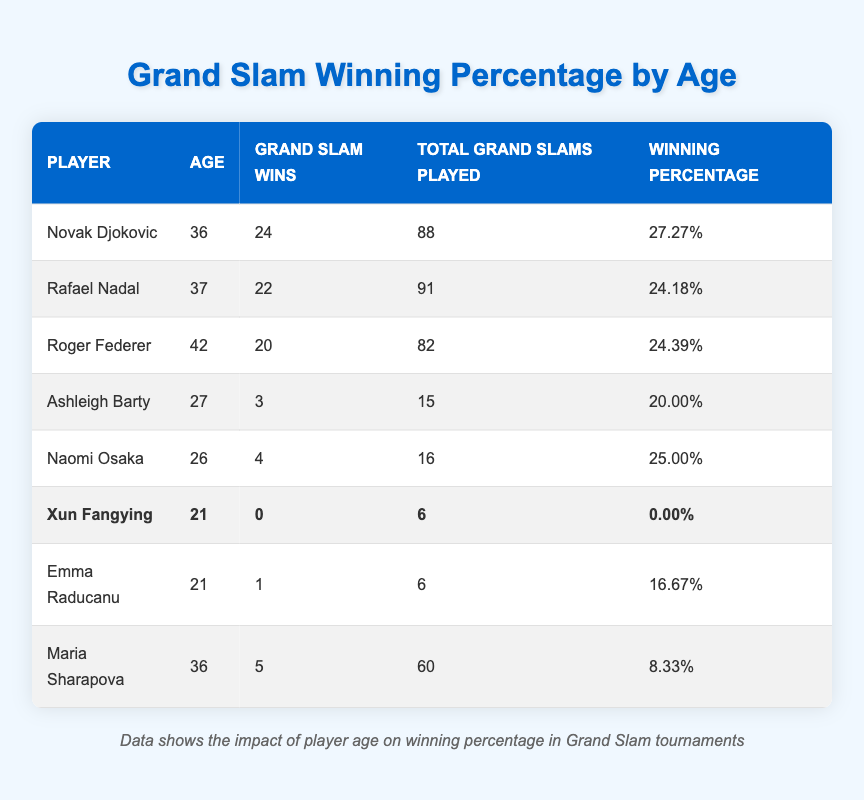What is the highest winning percentage in the table? To find the highest winning percentage, I will scan through the "Winning Percentage" column in the table. The players listed are Novak Djokovic with 27.27%, Rafael Nadal with 24.18%, Roger Federer with 24.39%, Ashleigh Barty with 20.00%, Naomi Osaka with 25.00%, Xun Fangying with 0.00%, Emma Raducanu with 16.67%, and Maria Sharapova with 8.33%. The highest among these is 27.27%, which belongs to Novak Djokovic.
Answer: 27.27% What is the average age of all players in the table? To find the average age, I will sum the ages of all players listed in the "Age" column: 36 + 37 + 42 + 27 + 26 + 21 + 21 + 36 = 306. There are 8 players in total. Therefore, the average age is 306 divided by 8, which equals 38.25.
Answer: 38.25 Does Xun Fangying have any Grand Slam wins? I will check the "Grand Slam Wins" column for Xun Fangying. According to the table, she has 0 Grand Slam wins. Since the value is explicitly stated as 0, the answer is no.
Answer: No Who has the lowest winning percentage in the table? To find the lowest winning percentage, I will look through the "Winning Percentage" column. Xun Fangying has a winning percentage of 0.00%, which is the lowest. All other percentages are higher than this value. Therefore, the answer is Xun Fangying.
Answer: Xun Fangying What is the difference in the number of Grand Slam wins between the oldest player and the youngest player? The oldest player is Roger Federer at age 42 with 20 Grand Slam wins, and the youngest player is Xun Fangying at age 21 with 0 Grand Slam wins. To find the difference in wins, I will subtract Xun Fangying's wins from Federer's wins: 20 - 0 = 20.
Answer: 20 